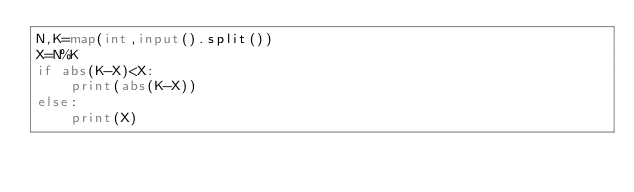<code> <loc_0><loc_0><loc_500><loc_500><_Python_>N,K=map(int,input().split())
X=N%K
if abs(K-X)<X:
    print(abs(K-X))
else:
    print(X)</code> 